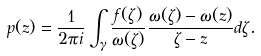Convert formula to latex. <formula><loc_0><loc_0><loc_500><loc_500>p ( z ) = \frac { 1 } { 2 \pi i } \int _ { \gamma } \frac { f ( \zeta ) } { \omega ( \zeta ) } \frac { \omega ( \zeta ) - \omega ( z ) } { \zeta - z } d \zeta .</formula> 